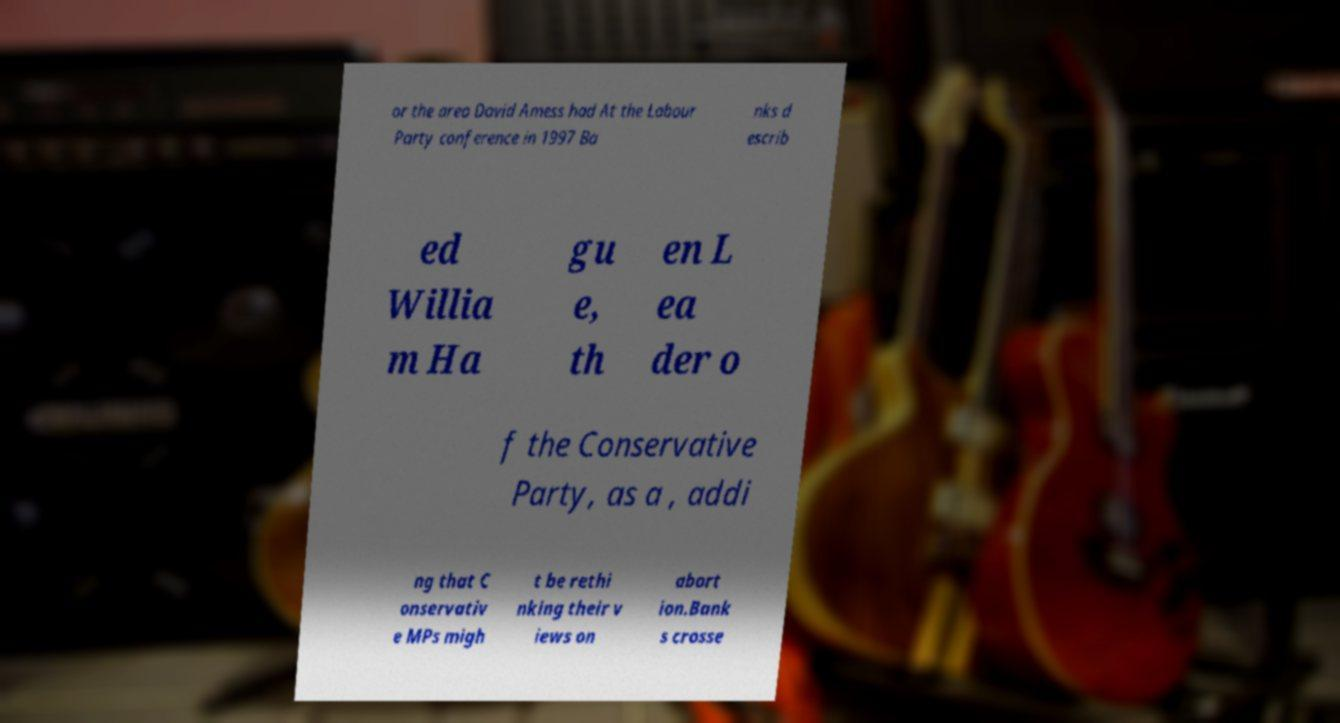Please read and relay the text visible in this image. What does it say? or the area David Amess had At the Labour Party conference in 1997 Ba nks d escrib ed Willia m Ha gu e, th en L ea der o f the Conservative Party, as a , addi ng that C onservativ e MPs migh t be rethi nking their v iews on abort ion.Bank s crosse 